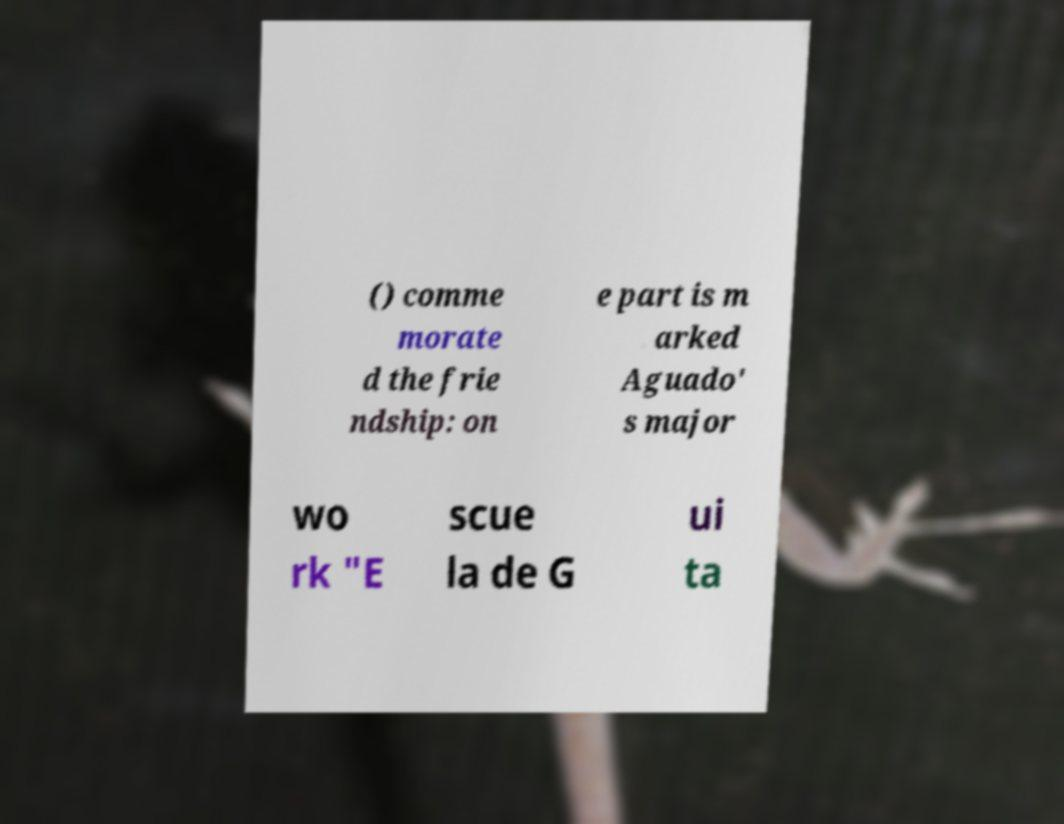I need the written content from this picture converted into text. Can you do that? () comme morate d the frie ndship: on e part is m arked Aguado' s major wo rk "E scue la de G ui ta 